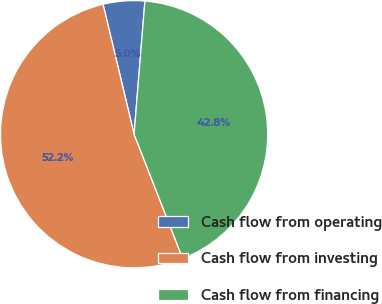<chart> <loc_0><loc_0><loc_500><loc_500><pie_chart><fcel>Cash flow from operating<fcel>Cash flow from investing<fcel>Cash flow from financing<nl><fcel>5.02%<fcel>52.2%<fcel>42.78%<nl></chart> 